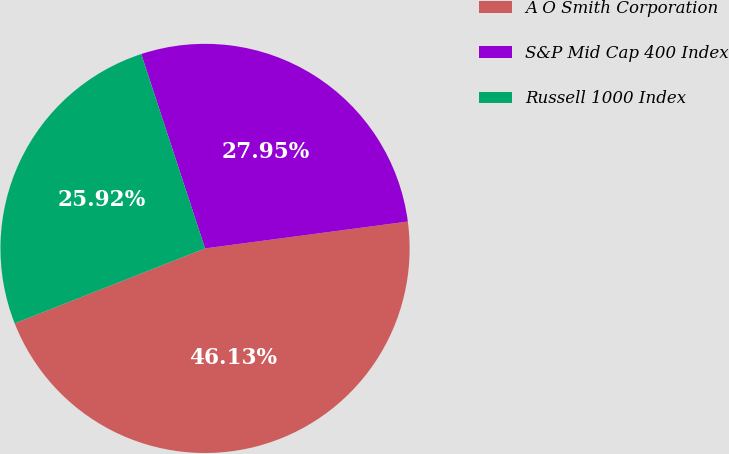<chart> <loc_0><loc_0><loc_500><loc_500><pie_chart><fcel>A O Smith Corporation<fcel>S&P Mid Cap 400 Index<fcel>Russell 1000 Index<nl><fcel>46.13%<fcel>27.95%<fcel>25.92%<nl></chart> 